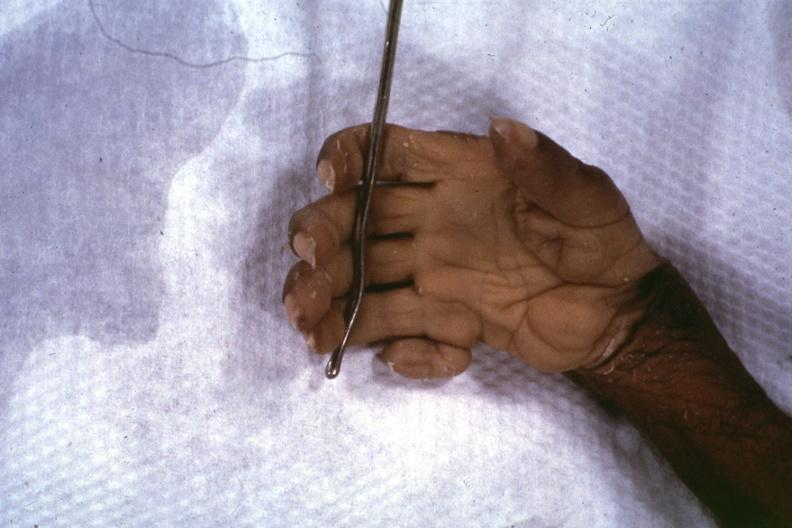re extremities present?
Answer the question using a single word or phrase. Extremities 